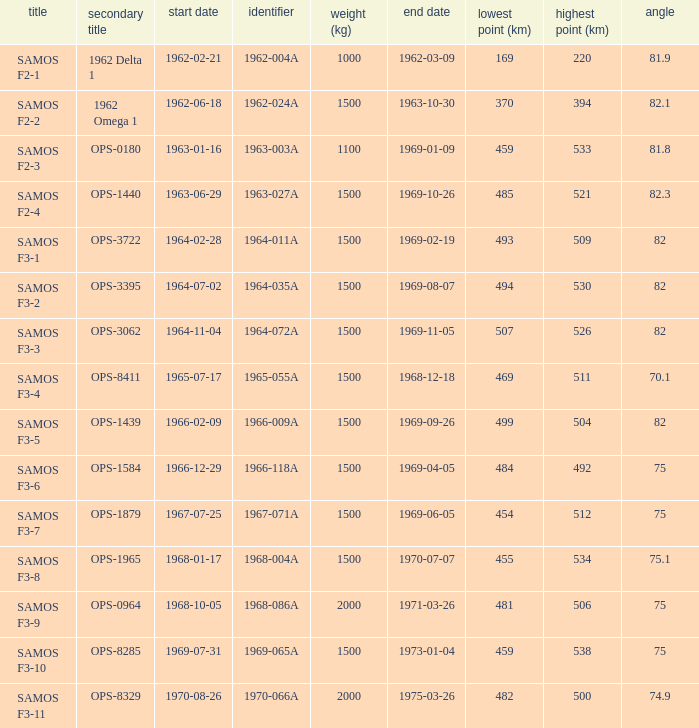What is the maximum apogee for samos f3-3? 526.0. 